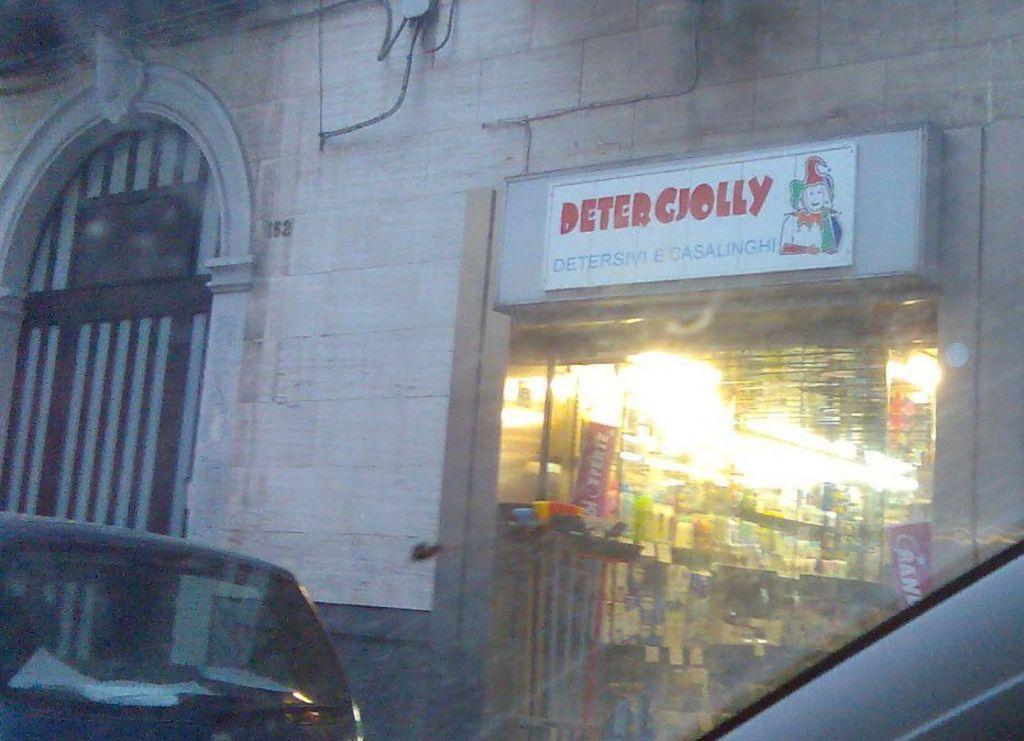Could you give a brief overview of what you see in this image? In this image we can see building, inside the building there is a shop where we have books and some other things and in front of the building we can see a car. 